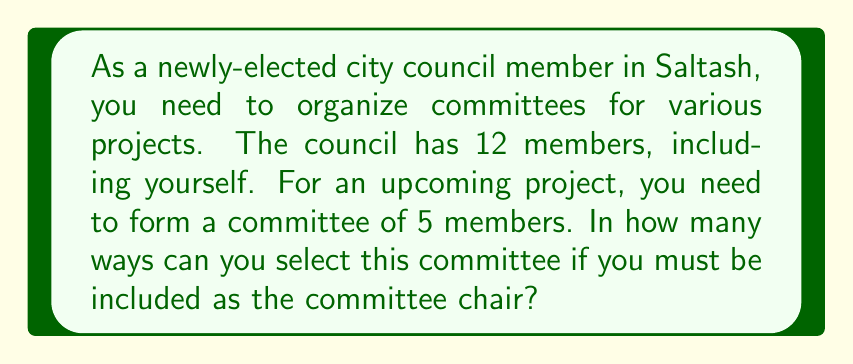Give your solution to this math problem. Let's approach this step-by-step:

1) First, we need to understand that you, as the committee chair, are already included in the committee. This means we only need to select 4 more members from the remaining 11 council members.

2) This is a combination problem. We're selecting 4 members from 11, where the order doesn't matter (it's not important who is selected first, second, etc.).

3) The formula for combinations is:

   $$C(n,r) = \frac{n!}{r!(n-r)!}$$

   Where $n$ is the total number of items to choose from, and $r$ is the number of items being chosen.

4) In this case, $n = 11$ (the remaining council members) and $r = 4$ (the number of additional committee members we need to select).

5) Plugging these numbers into our formula:

   $$C(11,4) = \frac{11!}{4!(11-4)!} = \frac{11!}{4!7!}$$

6) Let's calculate this:
   
   $$\frac{11 * 10 * 9 * 8 * 7!}{(4 * 3 * 2 * 1) * 7!}$$

7) The 7! cancels out in the numerator and denominator:

   $$\frac{11 * 10 * 9 * 8}{4 * 3 * 2 * 1} = \frac{7920}{24} = 330$$

Therefore, there are 330 possible ways to form the committee.
Answer: 330 